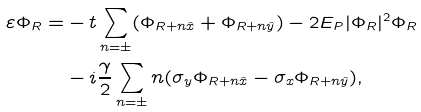<formula> <loc_0><loc_0><loc_500><loc_500>\varepsilon \Phi _ { R } = & - t \sum _ { n = \pm } ( \Phi _ { R + n \hat { x } } + \Phi _ { R + n \hat { y } } ) - 2 E _ { P } | \Phi _ { R } | ^ { 2 } \Phi _ { R } \\ & - i \frac { \gamma } { 2 } \sum _ { n = \pm } n ( \sigma _ { y } \Phi _ { R + n \hat { x } } - \sigma _ { x } \Phi _ { R + n \hat { y } } ) ,</formula> 